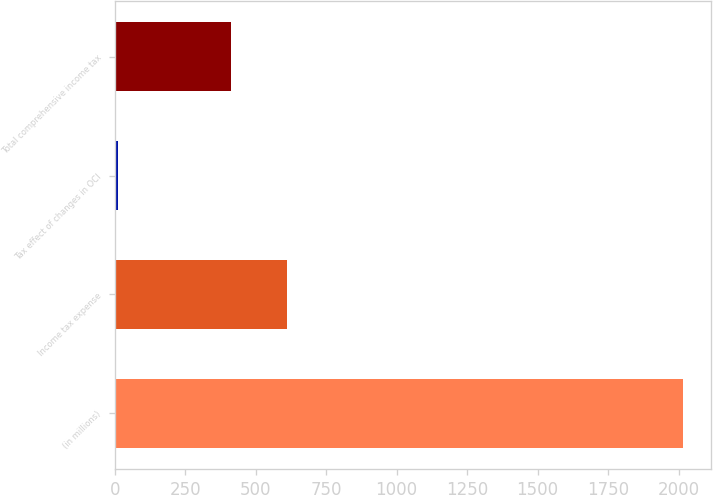Convert chart. <chart><loc_0><loc_0><loc_500><loc_500><bar_chart><fcel>(in millions)<fcel>Income tax expense<fcel>Tax effect of changes in OCI<fcel>Total comprehensive income tax<nl><fcel>2015<fcel>611.3<fcel>12<fcel>411<nl></chart> 